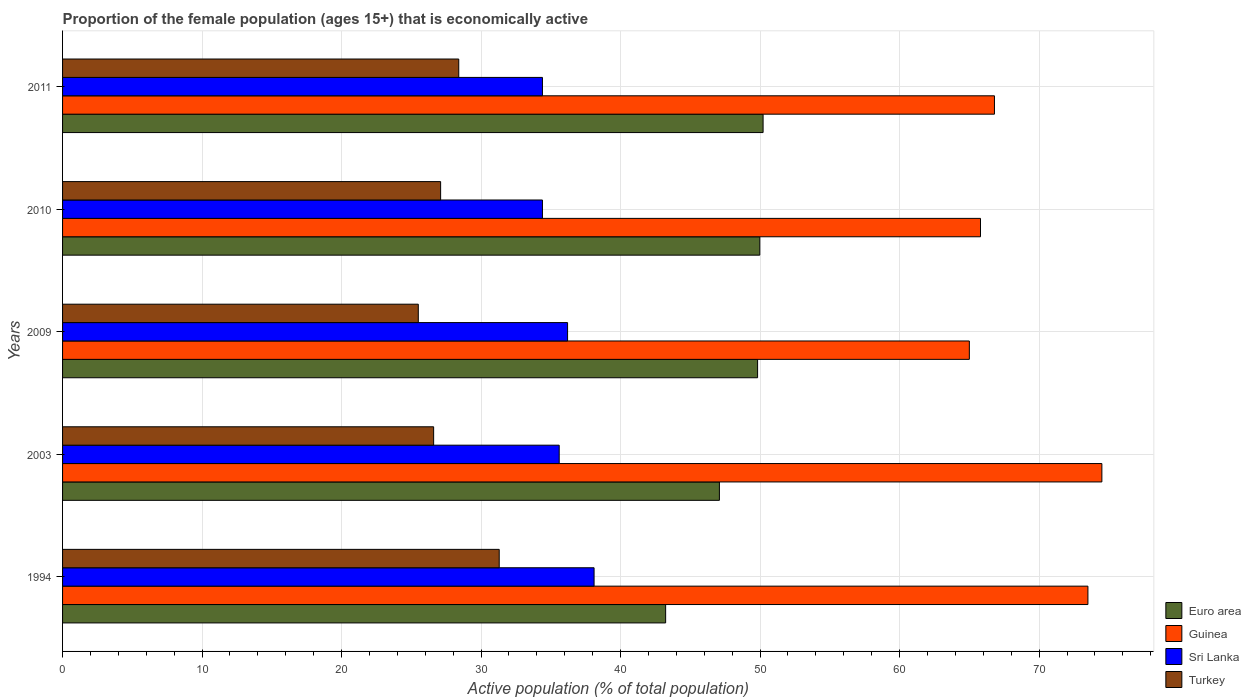How many groups of bars are there?
Keep it short and to the point. 5. How many bars are there on the 1st tick from the top?
Give a very brief answer. 4. How many bars are there on the 3rd tick from the bottom?
Make the answer very short. 4. In how many cases, is the number of bars for a given year not equal to the number of legend labels?
Offer a very short reply. 0. What is the proportion of the female population that is economically active in Turkey in 1994?
Provide a succinct answer. 31.3. Across all years, what is the maximum proportion of the female population that is economically active in Guinea?
Offer a very short reply. 74.5. Across all years, what is the minimum proportion of the female population that is economically active in Turkey?
Ensure brevity in your answer.  25.5. In which year was the proportion of the female population that is economically active in Euro area maximum?
Your answer should be very brief. 2011. What is the total proportion of the female population that is economically active in Guinea in the graph?
Your response must be concise. 345.6. What is the difference between the proportion of the female population that is economically active in Sri Lanka in 1994 and that in 2009?
Make the answer very short. 1.9. What is the difference between the proportion of the female population that is economically active in Turkey in 2009 and the proportion of the female population that is economically active in Sri Lanka in 2003?
Give a very brief answer. -10.1. What is the average proportion of the female population that is economically active in Euro area per year?
Provide a short and direct response. 48.07. In the year 2003, what is the difference between the proportion of the female population that is economically active in Sri Lanka and proportion of the female population that is economically active in Euro area?
Give a very brief answer. -11.48. What is the ratio of the proportion of the female population that is economically active in Guinea in 2009 to that in 2011?
Your answer should be compact. 0.97. Is the difference between the proportion of the female population that is economically active in Sri Lanka in 2009 and 2010 greater than the difference between the proportion of the female population that is economically active in Euro area in 2009 and 2010?
Keep it short and to the point. Yes. What is the difference between the highest and the lowest proportion of the female population that is economically active in Guinea?
Ensure brevity in your answer.  9.5. In how many years, is the proportion of the female population that is economically active in Guinea greater than the average proportion of the female population that is economically active in Guinea taken over all years?
Provide a succinct answer. 2. Is the sum of the proportion of the female population that is economically active in Turkey in 2009 and 2010 greater than the maximum proportion of the female population that is economically active in Euro area across all years?
Offer a terse response. Yes. Is it the case that in every year, the sum of the proportion of the female population that is economically active in Sri Lanka and proportion of the female population that is economically active in Turkey is greater than the sum of proportion of the female population that is economically active in Guinea and proportion of the female population that is economically active in Euro area?
Make the answer very short. No. What does the 3rd bar from the top in 2009 represents?
Make the answer very short. Guinea. What does the 3rd bar from the bottom in 2010 represents?
Provide a succinct answer. Sri Lanka. Is it the case that in every year, the sum of the proportion of the female population that is economically active in Sri Lanka and proportion of the female population that is economically active in Euro area is greater than the proportion of the female population that is economically active in Guinea?
Your answer should be compact. Yes. How many bars are there?
Make the answer very short. 20. How many years are there in the graph?
Ensure brevity in your answer.  5. What is the difference between two consecutive major ticks on the X-axis?
Give a very brief answer. 10. Does the graph contain any zero values?
Your answer should be compact. No. Where does the legend appear in the graph?
Provide a succinct answer. Bottom right. How many legend labels are there?
Ensure brevity in your answer.  4. What is the title of the graph?
Provide a short and direct response. Proportion of the female population (ages 15+) that is economically active. What is the label or title of the X-axis?
Offer a very short reply. Active population (% of total population). What is the label or title of the Y-axis?
Give a very brief answer. Years. What is the Active population (% of total population) in Euro area in 1994?
Provide a succinct answer. 43.23. What is the Active population (% of total population) of Guinea in 1994?
Give a very brief answer. 73.5. What is the Active population (% of total population) of Sri Lanka in 1994?
Offer a very short reply. 38.1. What is the Active population (% of total population) of Turkey in 1994?
Provide a succinct answer. 31.3. What is the Active population (% of total population) in Euro area in 2003?
Offer a very short reply. 47.08. What is the Active population (% of total population) of Guinea in 2003?
Your answer should be compact. 74.5. What is the Active population (% of total population) of Sri Lanka in 2003?
Ensure brevity in your answer.  35.6. What is the Active population (% of total population) in Turkey in 2003?
Your answer should be compact. 26.6. What is the Active population (% of total population) in Euro area in 2009?
Provide a succinct answer. 49.82. What is the Active population (% of total population) of Guinea in 2009?
Offer a terse response. 65. What is the Active population (% of total population) in Sri Lanka in 2009?
Ensure brevity in your answer.  36.2. What is the Active population (% of total population) in Euro area in 2010?
Provide a succinct answer. 49.98. What is the Active population (% of total population) in Guinea in 2010?
Your answer should be very brief. 65.8. What is the Active population (% of total population) of Sri Lanka in 2010?
Make the answer very short. 34.4. What is the Active population (% of total population) in Turkey in 2010?
Offer a terse response. 27.1. What is the Active population (% of total population) in Euro area in 2011?
Offer a terse response. 50.22. What is the Active population (% of total population) of Guinea in 2011?
Your answer should be compact. 66.8. What is the Active population (% of total population) of Sri Lanka in 2011?
Provide a succinct answer. 34.4. What is the Active population (% of total population) of Turkey in 2011?
Provide a succinct answer. 28.4. Across all years, what is the maximum Active population (% of total population) in Euro area?
Offer a very short reply. 50.22. Across all years, what is the maximum Active population (% of total population) in Guinea?
Your response must be concise. 74.5. Across all years, what is the maximum Active population (% of total population) of Sri Lanka?
Your answer should be compact. 38.1. Across all years, what is the maximum Active population (% of total population) of Turkey?
Your answer should be very brief. 31.3. Across all years, what is the minimum Active population (% of total population) of Euro area?
Ensure brevity in your answer.  43.23. Across all years, what is the minimum Active population (% of total population) in Guinea?
Your response must be concise. 65. Across all years, what is the minimum Active population (% of total population) of Sri Lanka?
Provide a succinct answer. 34.4. What is the total Active population (% of total population) in Euro area in the graph?
Offer a very short reply. 240.33. What is the total Active population (% of total population) of Guinea in the graph?
Provide a short and direct response. 345.6. What is the total Active population (% of total population) of Sri Lanka in the graph?
Ensure brevity in your answer.  178.7. What is the total Active population (% of total population) in Turkey in the graph?
Your response must be concise. 138.9. What is the difference between the Active population (% of total population) of Euro area in 1994 and that in 2003?
Your response must be concise. -3.85. What is the difference between the Active population (% of total population) in Sri Lanka in 1994 and that in 2003?
Give a very brief answer. 2.5. What is the difference between the Active population (% of total population) in Turkey in 1994 and that in 2003?
Give a very brief answer. 4.7. What is the difference between the Active population (% of total population) of Euro area in 1994 and that in 2009?
Give a very brief answer. -6.59. What is the difference between the Active population (% of total population) of Guinea in 1994 and that in 2009?
Provide a short and direct response. 8.5. What is the difference between the Active population (% of total population) in Turkey in 1994 and that in 2009?
Keep it short and to the point. 5.8. What is the difference between the Active population (% of total population) of Euro area in 1994 and that in 2010?
Give a very brief answer. -6.75. What is the difference between the Active population (% of total population) of Guinea in 1994 and that in 2010?
Provide a short and direct response. 7.7. What is the difference between the Active population (% of total population) in Euro area in 1994 and that in 2011?
Offer a very short reply. -6.99. What is the difference between the Active population (% of total population) in Guinea in 1994 and that in 2011?
Offer a very short reply. 6.7. What is the difference between the Active population (% of total population) of Turkey in 1994 and that in 2011?
Give a very brief answer. 2.9. What is the difference between the Active population (% of total population) of Euro area in 2003 and that in 2009?
Your answer should be compact. -2.74. What is the difference between the Active population (% of total population) in Guinea in 2003 and that in 2009?
Provide a succinct answer. 9.5. What is the difference between the Active population (% of total population) in Sri Lanka in 2003 and that in 2009?
Make the answer very short. -0.6. What is the difference between the Active population (% of total population) in Euro area in 2003 and that in 2010?
Your answer should be very brief. -2.9. What is the difference between the Active population (% of total population) in Turkey in 2003 and that in 2010?
Give a very brief answer. -0.5. What is the difference between the Active population (% of total population) in Euro area in 2003 and that in 2011?
Offer a very short reply. -3.13. What is the difference between the Active population (% of total population) in Guinea in 2003 and that in 2011?
Your response must be concise. 7.7. What is the difference between the Active population (% of total population) in Euro area in 2009 and that in 2010?
Offer a very short reply. -0.16. What is the difference between the Active population (% of total population) of Turkey in 2009 and that in 2010?
Offer a very short reply. -1.6. What is the difference between the Active population (% of total population) in Euro area in 2009 and that in 2011?
Your response must be concise. -0.39. What is the difference between the Active population (% of total population) of Guinea in 2009 and that in 2011?
Give a very brief answer. -1.8. What is the difference between the Active population (% of total population) of Euro area in 2010 and that in 2011?
Make the answer very short. -0.24. What is the difference between the Active population (% of total population) in Guinea in 2010 and that in 2011?
Give a very brief answer. -1. What is the difference between the Active population (% of total population) of Euro area in 1994 and the Active population (% of total population) of Guinea in 2003?
Make the answer very short. -31.27. What is the difference between the Active population (% of total population) in Euro area in 1994 and the Active population (% of total population) in Sri Lanka in 2003?
Offer a very short reply. 7.63. What is the difference between the Active population (% of total population) of Euro area in 1994 and the Active population (% of total population) of Turkey in 2003?
Keep it short and to the point. 16.63. What is the difference between the Active population (% of total population) in Guinea in 1994 and the Active population (% of total population) in Sri Lanka in 2003?
Your answer should be very brief. 37.9. What is the difference between the Active population (% of total population) in Guinea in 1994 and the Active population (% of total population) in Turkey in 2003?
Your answer should be compact. 46.9. What is the difference between the Active population (% of total population) in Sri Lanka in 1994 and the Active population (% of total population) in Turkey in 2003?
Your response must be concise. 11.5. What is the difference between the Active population (% of total population) of Euro area in 1994 and the Active population (% of total population) of Guinea in 2009?
Offer a very short reply. -21.77. What is the difference between the Active population (% of total population) in Euro area in 1994 and the Active population (% of total population) in Sri Lanka in 2009?
Provide a succinct answer. 7.03. What is the difference between the Active population (% of total population) in Euro area in 1994 and the Active population (% of total population) in Turkey in 2009?
Ensure brevity in your answer.  17.73. What is the difference between the Active population (% of total population) in Guinea in 1994 and the Active population (% of total population) in Sri Lanka in 2009?
Ensure brevity in your answer.  37.3. What is the difference between the Active population (% of total population) of Guinea in 1994 and the Active population (% of total population) of Turkey in 2009?
Ensure brevity in your answer.  48. What is the difference between the Active population (% of total population) in Sri Lanka in 1994 and the Active population (% of total population) in Turkey in 2009?
Ensure brevity in your answer.  12.6. What is the difference between the Active population (% of total population) in Euro area in 1994 and the Active population (% of total population) in Guinea in 2010?
Offer a terse response. -22.57. What is the difference between the Active population (% of total population) of Euro area in 1994 and the Active population (% of total population) of Sri Lanka in 2010?
Your answer should be compact. 8.83. What is the difference between the Active population (% of total population) in Euro area in 1994 and the Active population (% of total population) in Turkey in 2010?
Offer a terse response. 16.13. What is the difference between the Active population (% of total population) of Guinea in 1994 and the Active population (% of total population) of Sri Lanka in 2010?
Your response must be concise. 39.1. What is the difference between the Active population (% of total population) in Guinea in 1994 and the Active population (% of total population) in Turkey in 2010?
Your response must be concise. 46.4. What is the difference between the Active population (% of total population) of Euro area in 1994 and the Active population (% of total population) of Guinea in 2011?
Your response must be concise. -23.57. What is the difference between the Active population (% of total population) in Euro area in 1994 and the Active population (% of total population) in Sri Lanka in 2011?
Provide a succinct answer. 8.83. What is the difference between the Active population (% of total population) of Euro area in 1994 and the Active population (% of total population) of Turkey in 2011?
Your answer should be compact. 14.83. What is the difference between the Active population (% of total population) in Guinea in 1994 and the Active population (% of total population) in Sri Lanka in 2011?
Your response must be concise. 39.1. What is the difference between the Active population (% of total population) in Guinea in 1994 and the Active population (% of total population) in Turkey in 2011?
Make the answer very short. 45.1. What is the difference between the Active population (% of total population) of Euro area in 2003 and the Active population (% of total population) of Guinea in 2009?
Your answer should be very brief. -17.92. What is the difference between the Active population (% of total population) in Euro area in 2003 and the Active population (% of total population) in Sri Lanka in 2009?
Your response must be concise. 10.88. What is the difference between the Active population (% of total population) of Euro area in 2003 and the Active population (% of total population) of Turkey in 2009?
Provide a succinct answer. 21.58. What is the difference between the Active population (% of total population) in Guinea in 2003 and the Active population (% of total population) in Sri Lanka in 2009?
Keep it short and to the point. 38.3. What is the difference between the Active population (% of total population) in Sri Lanka in 2003 and the Active population (% of total population) in Turkey in 2009?
Offer a very short reply. 10.1. What is the difference between the Active population (% of total population) in Euro area in 2003 and the Active population (% of total population) in Guinea in 2010?
Provide a succinct answer. -18.72. What is the difference between the Active population (% of total population) in Euro area in 2003 and the Active population (% of total population) in Sri Lanka in 2010?
Your response must be concise. 12.68. What is the difference between the Active population (% of total population) of Euro area in 2003 and the Active population (% of total population) of Turkey in 2010?
Offer a terse response. 19.98. What is the difference between the Active population (% of total population) in Guinea in 2003 and the Active population (% of total population) in Sri Lanka in 2010?
Your response must be concise. 40.1. What is the difference between the Active population (% of total population) of Guinea in 2003 and the Active population (% of total population) of Turkey in 2010?
Ensure brevity in your answer.  47.4. What is the difference between the Active population (% of total population) of Euro area in 2003 and the Active population (% of total population) of Guinea in 2011?
Offer a terse response. -19.72. What is the difference between the Active population (% of total population) of Euro area in 2003 and the Active population (% of total population) of Sri Lanka in 2011?
Your response must be concise. 12.68. What is the difference between the Active population (% of total population) of Euro area in 2003 and the Active population (% of total population) of Turkey in 2011?
Your answer should be compact. 18.68. What is the difference between the Active population (% of total population) of Guinea in 2003 and the Active population (% of total population) of Sri Lanka in 2011?
Your response must be concise. 40.1. What is the difference between the Active population (% of total population) in Guinea in 2003 and the Active population (% of total population) in Turkey in 2011?
Ensure brevity in your answer.  46.1. What is the difference between the Active population (% of total population) in Euro area in 2009 and the Active population (% of total population) in Guinea in 2010?
Offer a terse response. -15.98. What is the difference between the Active population (% of total population) of Euro area in 2009 and the Active population (% of total population) of Sri Lanka in 2010?
Offer a terse response. 15.42. What is the difference between the Active population (% of total population) in Euro area in 2009 and the Active population (% of total population) in Turkey in 2010?
Your answer should be very brief. 22.72. What is the difference between the Active population (% of total population) in Guinea in 2009 and the Active population (% of total population) in Sri Lanka in 2010?
Your answer should be compact. 30.6. What is the difference between the Active population (% of total population) in Guinea in 2009 and the Active population (% of total population) in Turkey in 2010?
Your answer should be compact. 37.9. What is the difference between the Active population (% of total population) of Euro area in 2009 and the Active population (% of total population) of Guinea in 2011?
Offer a very short reply. -16.98. What is the difference between the Active population (% of total population) of Euro area in 2009 and the Active population (% of total population) of Sri Lanka in 2011?
Provide a succinct answer. 15.42. What is the difference between the Active population (% of total population) in Euro area in 2009 and the Active population (% of total population) in Turkey in 2011?
Offer a very short reply. 21.42. What is the difference between the Active population (% of total population) of Guinea in 2009 and the Active population (% of total population) of Sri Lanka in 2011?
Your response must be concise. 30.6. What is the difference between the Active population (% of total population) in Guinea in 2009 and the Active population (% of total population) in Turkey in 2011?
Make the answer very short. 36.6. What is the difference between the Active population (% of total population) of Euro area in 2010 and the Active population (% of total population) of Guinea in 2011?
Keep it short and to the point. -16.82. What is the difference between the Active population (% of total population) in Euro area in 2010 and the Active population (% of total population) in Sri Lanka in 2011?
Keep it short and to the point. 15.58. What is the difference between the Active population (% of total population) of Euro area in 2010 and the Active population (% of total population) of Turkey in 2011?
Make the answer very short. 21.58. What is the difference between the Active population (% of total population) in Guinea in 2010 and the Active population (% of total population) in Sri Lanka in 2011?
Ensure brevity in your answer.  31.4. What is the difference between the Active population (% of total population) in Guinea in 2010 and the Active population (% of total population) in Turkey in 2011?
Your answer should be compact. 37.4. What is the difference between the Active population (% of total population) of Sri Lanka in 2010 and the Active population (% of total population) of Turkey in 2011?
Your answer should be compact. 6. What is the average Active population (% of total population) in Euro area per year?
Provide a short and direct response. 48.07. What is the average Active population (% of total population) of Guinea per year?
Offer a terse response. 69.12. What is the average Active population (% of total population) in Sri Lanka per year?
Provide a succinct answer. 35.74. What is the average Active population (% of total population) in Turkey per year?
Your response must be concise. 27.78. In the year 1994, what is the difference between the Active population (% of total population) of Euro area and Active population (% of total population) of Guinea?
Your answer should be compact. -30.27. In the year 1994, what is the difference between the Active population (% of total population) in Euro area and Active population (% of total population) in Sri Lanka?
Make the answer very short. 5.13. In the year 1994, what is the difference between the Active population (% of total population) of Euro area and Active population (% of total population) of Turkey?
Your response must be concise. 11.93. In the year 1994, what is the difference between the Active population (% of total population) of Guinea and Active population (% of total population) of Sri Lanka?
Offer a terse response. 35.4. In the year 1994, what is the difference between the Active population (% of total population) in Guinea and Active population (% of total population) in Turkey?
Offer a terse response. 42.2. In the year 1994, what is the difference between the Active population (% of total population) in Sri Lanka and Active population (% of total population) in Turkey?
Your answer should be very brief. 6.8. In the year 2003, what is the difference between the Active population (% of total population) in Euro area and Active population (% of total population) in Guinea?
Offer a very short reply. -27.42. In the year 2003, what is the difference between the Active population (% of total population) in Euro area and Active population (% of total population) in Sri Lanka?
Your answer should be compact. 11.48. In the year 2003, what is the difference between the Active population (% of total population) of Euro area and Active population (% of total population) of Turkey?
Give a very brief answer. 20.48. In the year 2003, what is the difference between the Active population (% of total population) in Guinea and Active population (% of total population) in Sri Lanka?
Your answer should be very brief. 38.9. In the year 2003, what is the difference between the Active population (% of total population) of Guinea and Active population (% of total population) of Turkey?
Offer a very short reply. 47.9. In the year 2009, what is the difference between the Active population (% of total population) of Euro area and Active population (% of total population) of Guinea?
Your answer should be compact. -15.18. In the year 2009, what is the difference between the Active population (% of total population) in Euro area and Active population (% of total population) in Sri Lanka?
Offer a terse response. 13.62. In the year 2009, what is the difference between the Active population (% of total population) of Euro area and Active population (% of total population) of Turkey?
Provide a succinct answer. 24.32. In the year 2009, what is the difference between the Active population (% of total population) of Guinea and Active population (% of total population) of Sri Lanka?
Ensure brevity in your answer.  28.8. In the year 2009, what is the difference between the Active population (% of total population) of Guinea and Active population (% of total population) of Turkey?
Your answer should be compact. 39.5. In the year 2010, what is the difference between the Active population (% of total population) in Euro area and Active population (% of total population) in Guinea?
Provide a succinct answer. -15.82. In the year 2010, what is the difference between the Active population (% of total population) of Euro area and Active population (% of total population) of Sri Lanka?
Keep it short and to the point. 15.58. In the year 2010, what is the difference between the Active population (% of total population) in Euro area and Active population (% of total population) in Turkey?
Make the answer very short. 22.88. In the year 2010, what is the difference between the Active population (% of total population) in Guinea and Active population (% of total population) in Sri Lanka?
Keep it short and to the point. 31.4. In the year 2010, what is the difference between the Active population (% of total population) in Guinea and Active population (% of total population) in Turkey?
Offer a very short reply. 38.7. In the year 2010, what is the difference between the Active population (% of total population) of Sri Lanka and Active population (% of total population) of Turkey?
Give a very brief answer. 7.3. In the year 2011, what is the difference between the Active population (% of total population) of Euro area and Active population (% of total population) of Guinea?
Ensure brevity in your answer.  -16.58. In the year 2011, what is the difference between the Active population (% of total population) in Euro area and Active population (% of total population) in Sri Lanka?
Make the answer very short. 15.82. In the year 2011, what is the difference between the Active population (% of total population) of Euro area and Active population (% of total population) of Turkey?
Offer a very short reply. 21.82. In the year 2011, what is the difference between the Active population (% of total population) of Guinea and Active population (% of total population) of Sri Lanka?
Keep it short and to the point. 32.4. In the year 2011, what is the difference between the Active population (% of total population) of Guinea and Active population (% of total population) of Turkey?
Provide a succinct answer. 38.4. What is the ratio of the Active population (% of total population) of Euro area in 1994 to that in 2003?
Ensure brevity in your answer.  0.92. What is the ratio of the Active population (% of total population) in Guinea in 1994 to that in 2003?
Provide a short and direct response. 0.99. What is the ratio of the Active population (% of total population) of Sri Lanka in 1994 to that in 2003?
Offer a terse response. 1.07. What is the ratio of the Active population (% of total population) in Turkey in 1994 to that in 2003?
Provide a short and direct response. 1.18. What is the ratio of the Active population (% of total population) of Euro area in 1994 to that in 2009?
Make the answer very short. 0.87. What is the ratio of the Active population (% of total population) of Guinea in 1994 to that in 2009?
Keep it short and to the point. 1.13. What is the ratio of the Active population (% of total population) in Sri Lanka in 1994 to that in 2009?
Ensure brevity in your answer.  1.05. What is the ratio of the Active population (% of total population) of Turkey in 1994 to that in 2009?
Give a very brief answer. 1.23. What is the ratio of the Active population (% of total population) of Euro area in 1994 to that in 2010?
Your response must be concise. 0.86. What is the ratio of the Active population (% of total population) of Guinea in 1994 to that in 2010?
Offer a very short reply. 1.12. What is the ratio of the Active population (% of total population) in Sri Lanka in 1994 to that in 2010?
Provide a succinct answer. 1.11. What is the ratio of the Active population (% of total population) in Turkey in 1994 to that in 2010?
Your response must be concise. 1.16. What is the ratio of the Active population (% of total population) in Euro area in 1994 to that in 2011?
Give a very brief answer. 0.86. What is the ratio of the Active population (% of total population) of Guinea in 1994 to that in 2011?
Your answer should be compact. 1.1. What is the ratio of the Active population (% of total population) in Sri Lanka in 1994 to that in 2011?
Offer a terse response. 1.11. What is the ratio of the Active population (% of total population) of Turkey in 1994 to that in 2011?
Offer a very short reply. 1.1. What is the ratio of the Active population (% of total population) in Euro area in 2003 to that in 2009?
Keep it short and to the point. 0.95. What is the ratio of the Active population (% of total population) in Guinea in 2003 to that in 2009?
Offer a terse response. 1.15. What is the ratio of the Active population (% of total population) in Sri Lanka in 2003 to that in 2009?
Your answer should be compact. 0.98. What is the ratio of the Active population (% of total population) of Turkey in 2003 to that in 2009?
Your answer should be compact. 1.04. What is the ratio of the Active population (% of total population) in Euro area in 2003 to that in 2010?
Provide a succinct answer. 0.94. What is the ratio of the Active population (% of total population) of Guinea in 2003 to that in 2010?
Your response must be concise. 1.13. What is the ratio of the Active population (% of total population) of Sri Lanka in 2003 to that in 2010?
Ensure brevity in your answer.  1.03. What is the ratio of the Active population (% of total population) of Turkey in 2003 to that in 2010?
Make the answer very short. 0.98. What is the ratio of the Active population (% of total population) of Euro area in 2003 to that in 2011?
Keep it short and to the point. 0.94. What is the ratio of the Active population (% of total population) of Guinea in 2003 to that in 2011?
Your answer should be compact. 1.12. What is the ratio of the Active population (% of total population) in Sri Lanka in 2003 to that in 2011?
Make the answer very short. 1.03. What is the ratio of the Active population (% of total population) of Turkey in 2003 to that in 2011?
Your answer should be very brief. 0.94. What is the ratio of the Active population (% of total population) in Guinea in 2009 to that in 2010?
Offer a terse response. 0.99. What is the ratio of the Active population (% of total population) in Sri Lanka in 2009 to that in 2010?
Provide a succinct answer. 1.05. What is the ratio of the Active population (% of total population) in Turkey in 2009 to that in 2010?
Ensure brevity in your answer.  0.94. What is the ratio of the Active population (% of total population) in Guinea in 2009 to that in 2011?
Ensure brevity in your answer.  0.97. What is the ratio of the Active population (% of total population) in Sri Lanka in 2009 to that in 2011?
Provide a short and direct response. 1.05. What is the ratio of the Active population (% of total population) in Turkey in 2009 to that in 2011?
Your response must be concise. 0.9. What is the ratio of the Active population (% of total population) of Turkey in 2010 to that in 2011?
Provide a short and direct response. 0.95. What is the difference between the highest and the second highest Active population (% of total population) of Euro area?
Your response must be concise. 0.24. What is the difference between the highest and the second highest Active population (% of total population) of Guinea?
Provide a short and direct response. 1. What is the difference between the highest and the lowest Active population (% of total population) of Euro area?
Offer a very short reply. 6.99. What is the difference between the highest and the lowest Active population (% of total population) of Sri Lanka?
Give a very brief answer. 3.7. 